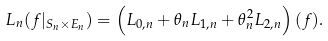<formula> <loc_0><loc_0><loc_500><loc_500>L _ { n } ( f | _ { S _ { n } \times E _ { n } } ) = \left ( L _ { 0 , n } + \theta _ { n } L _ { 1 , n } + \theta _ { n } ^ { 2 } L _ { 2 , n } \right ) ( f ) .</formula> 